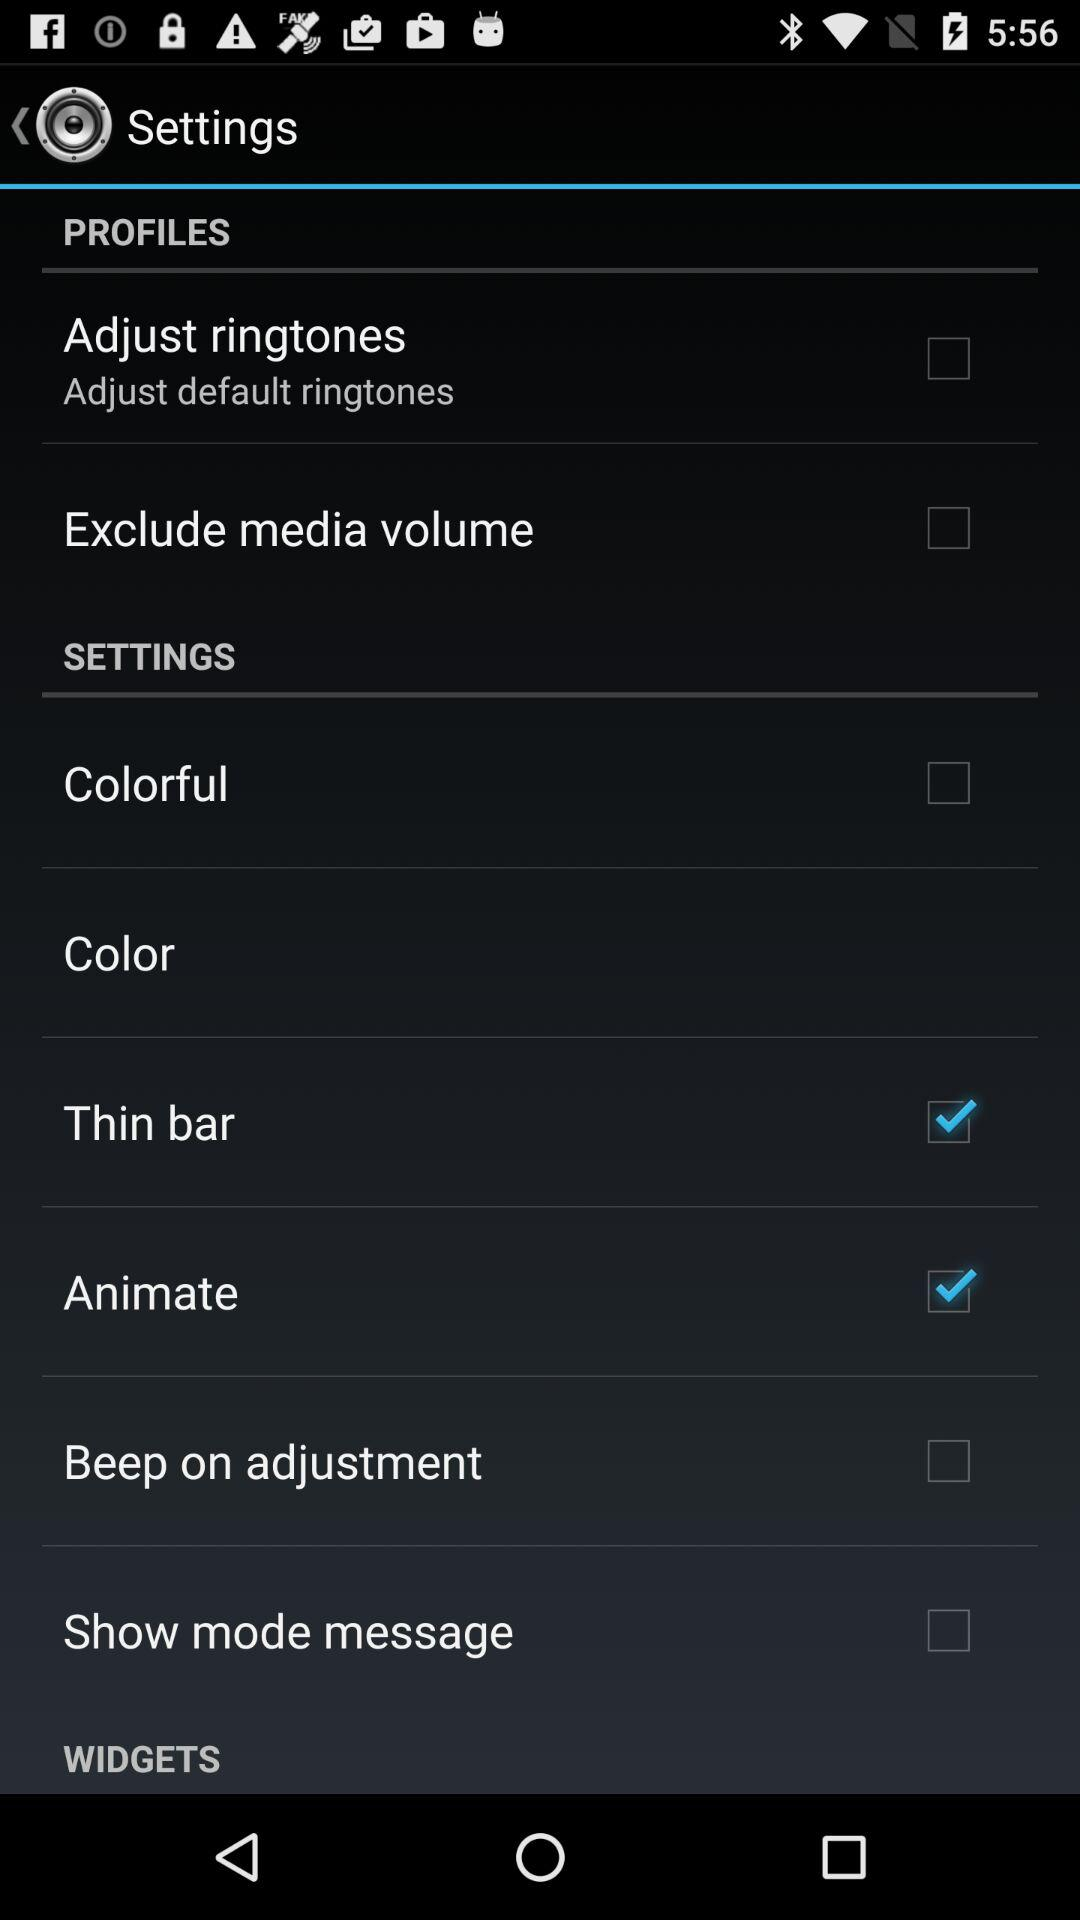What is the current status of "Adjust ringtones"? The current status is "off". 